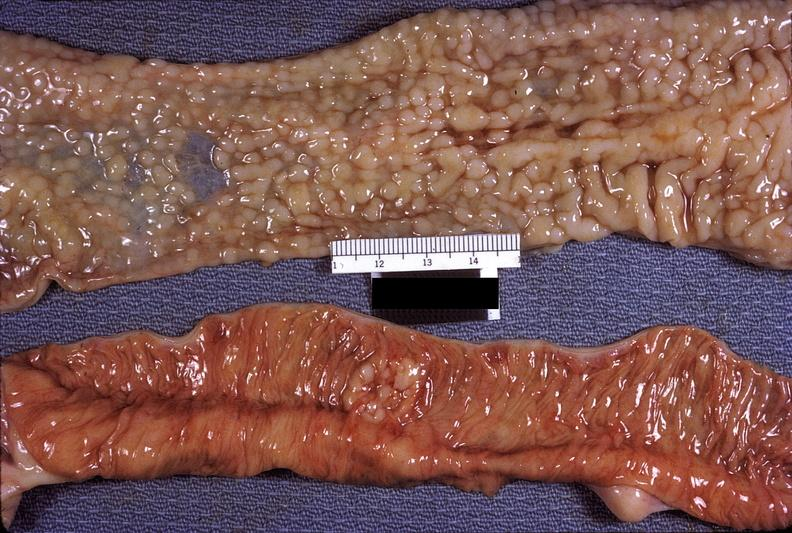s gastrointestinal present?
Answer the question using a single word or phrase. Yes 